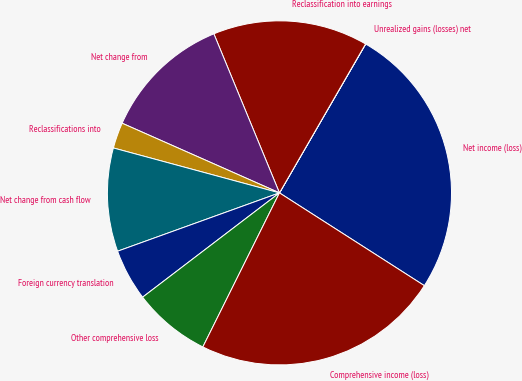Convert chart to OTSL. <chart><loc_0><loc_0><loc_500><loc_500><pie_chart><fcel>Net income (loss)<fcel>Unrealized gains (losses) net<fcel>Reclassification into earnings<fcel>Net change from<fcel>Reclassifications into<fcel>Net change from cash flow<fcel>Foreign currency translation<fcel>Other comprehensive loss<fcel>Comprehensive income (loss)<nl><fcel>25.71%<fcel>0.01%<fcel>14.57%<fcel>12.14%<fcel>2.43%<fcel>9.71%<fcel>4.86%<fcel>7.29%<fcel>23.28%<nl></chart> 